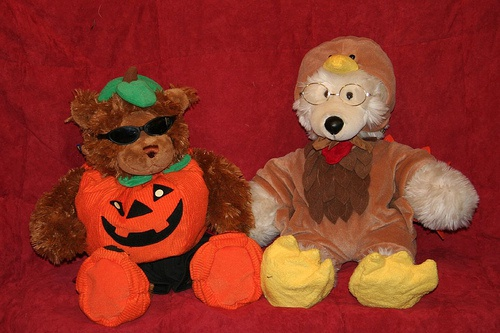Describe the objects in this image and their specific colors. I can see couch in maroon, brown, and red tones, teddy bear in maroon, red, and black tones, and teddy bear in maroon, brown, and orange tones in this image. 